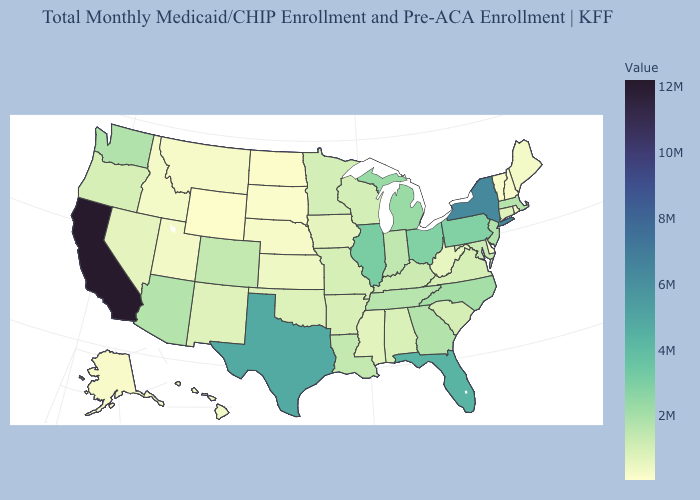Does the map have missing data?
Be succinct. No. Does Texas have the highest value in the South?
Write a very short answer. Yes. Does Alaska have a lower value than New York?
Give a very brief answer. Yes. Among the states that border Colorado , which have the lowest value?
Answer briefly. Wyoming. Among the states that border Idaho , which have the lowest value?
Write a very short answer. Wyoming. 